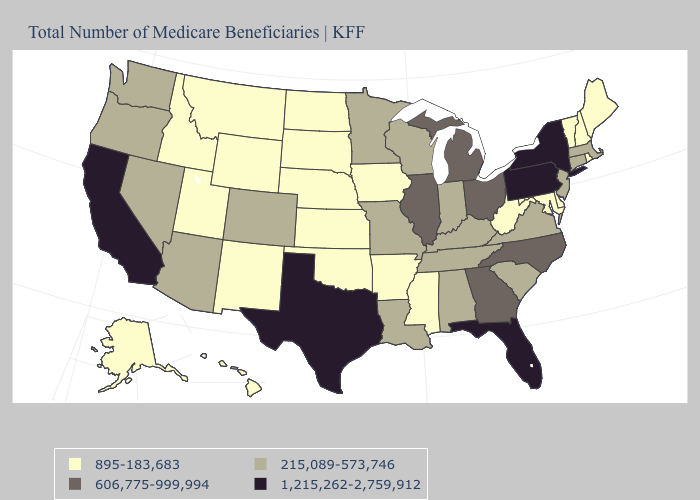Among the states that border South Dakota , which have the lowest value?
Give a very brief answer. Iowa, Montana, Nebraska, North Dakota, Wyoming. Name the states that have a value in the range 1,215,262-2,759,912?
Be succinct. California, Florida, New York, Pennsylvania, Texas. Does Virginia have a higher value than South Dakota?
Write a very short answer. Yes. Among the states that border Nebraska , which have the lowest value?
Give a very brief answer. Iowa, Kansas, South Dakota, Wyoming. Which states have the lowest value in the USA?
Short answer required. Alaska, Arkansas, Delaware, Hawaii, Idaho, Iowa, Kansas, Maine, Maryland, Mississippi, Montana, Nebraska, New Hampshire, New Mexico, North Dakota, Oklahoma, Rhode Island, South Dakota, Utah, Vermont, West Virginia, Wyoming. Does Indiana have the same value as Tennessee?
Write a very short answer. Yes. Name the states that have a value in the range 215,089-573,746?
Answer briefly. Alabama, Arizona, Colorado, Connecticut, Indiana, Kentucky, Louisiana, Massachusetts, Minnesota, Missouri, Nevada, New Jersey, Oregon, South Carolina, Tennessee, Virginia, Washington, Wisconsin. What is the value of Georgia?
Answer briefly. 606,775-999,994. Among the states that border New Jersey , which have the lowest value?
Answer briefly. Delaware. Does Maryland have the highest value in the USA?
Write a very short answer. No. Which states have the highest value in the USA?
Quick response, please. California, Florida, New York, Pennsylvania, Texas. What is the value of Florida?
Write a very short answer. 1,215,262-2,759,912. What is the lowest value in the Northeast?
Short answer required. 895-183,683. Name the states that have a value in the range 606,775-999,994?
Write a very short answer. Georgia, Illinois, Michigan, North Carolina, Ohio. Which states have the highest value in the USA?
Write a very short answer. California, Florida, New York, Pennsylvania, Texas. 